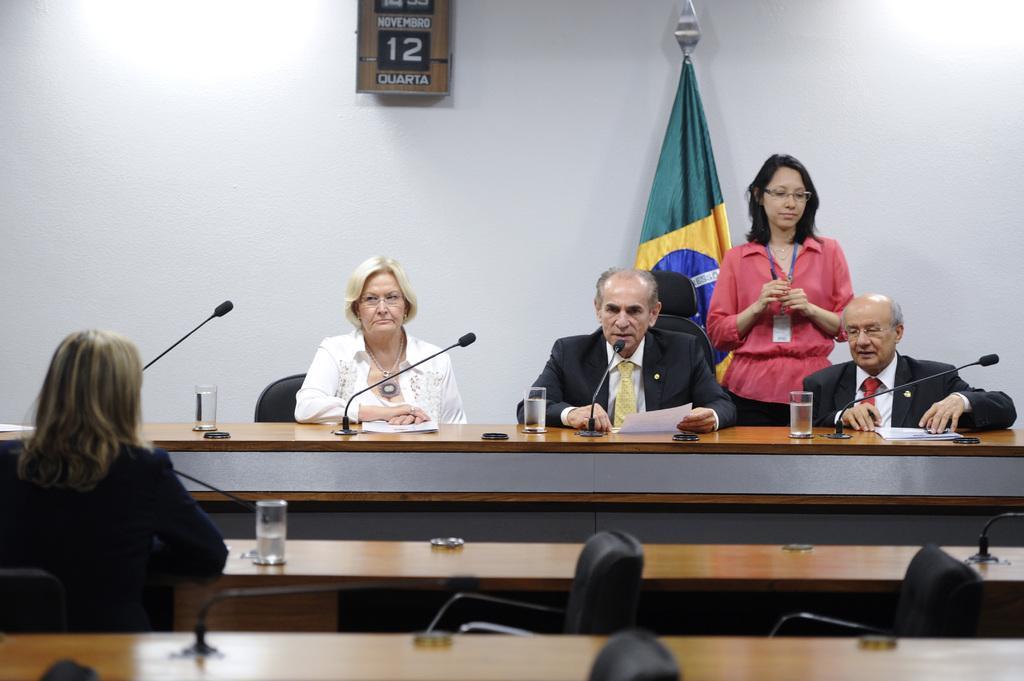Can you describe this image briefly? In this image there are group of persons sitting in chair near the podium , and on table there are glasses, microphones, papers and at back side there is a woman standing , a flag , frame or a calendar attached to wall. 